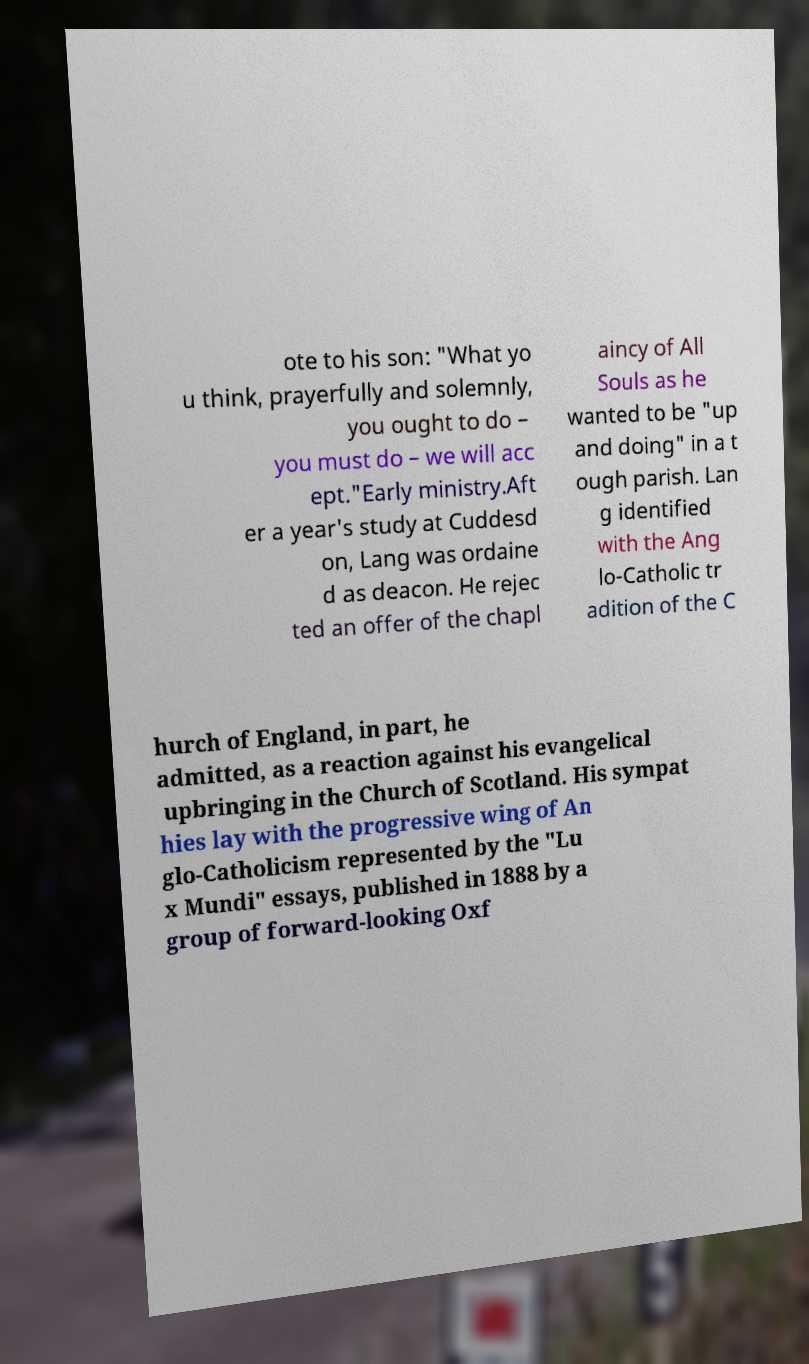There's text embedded in this image that I need extracted. Can you transcribe it verbatim? ote to his son: "What yo u think, prayerfully and solemnly, you ought to do – you must do – we will acc ept."Early ministry.Aft er a year's study at Cuddesd on, Lang was ordaine d as deacon. He rejec ted an offer of the chapl aincy of All Souls as he wanted to be "up and doing" in a t ough parish. Lan g identified with the Ang lo-Catholic tr adition of the C hurch of England, in part, he admitted, as a reaction against his evangelical upbringing in the Church of Scotland. His sympat hies lay with the progressive wing of An glo-Catholicism represented by the "Lu x Mundi" essays, published in 1888 by a group of forward-looking Oxf 